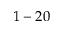<formula> <loc_0><loc_0><loc_500><loc_500>1 - 2 0</formula> 